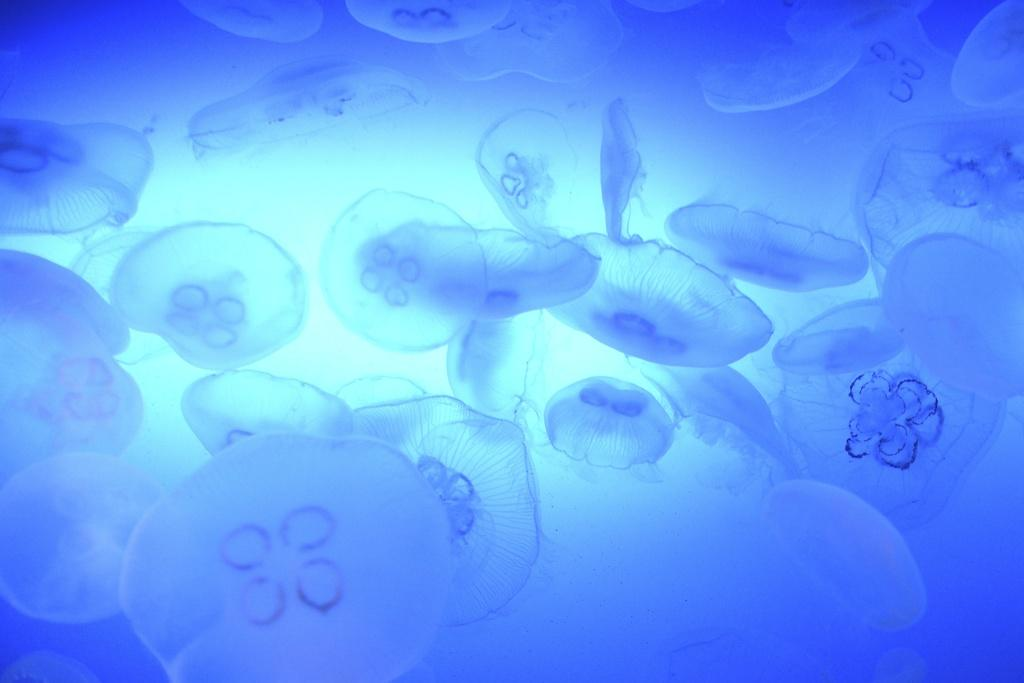What type of animals can be seen in the image? There are aquatic animals in the image. What type of umbrella is being used by the governor in the image? There is no governor or umbrella present in the image; it features aquatic animals. 